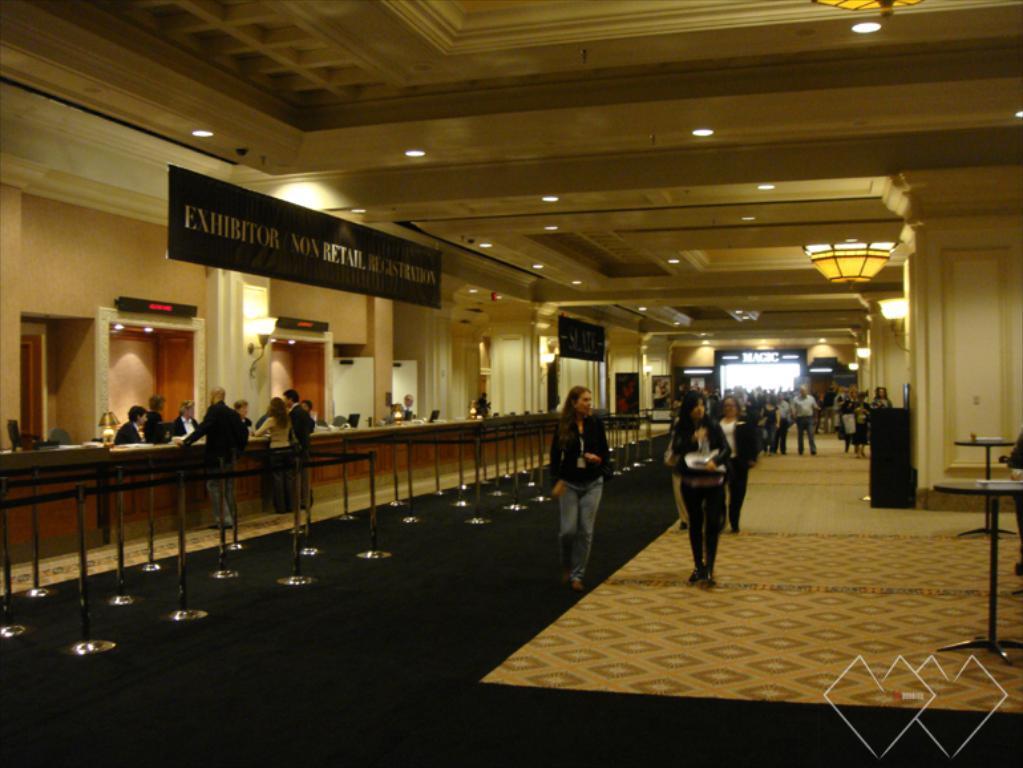Describe this image in one or two sentences. In this image we can see a group of people standing on the floor. We can also see some poles with ribbons, tables, some boards with text on them, pillars and a roof with some ceiling lights and a chandelier. On the left side we can see some people sitting beside a table containing some objects on it. 